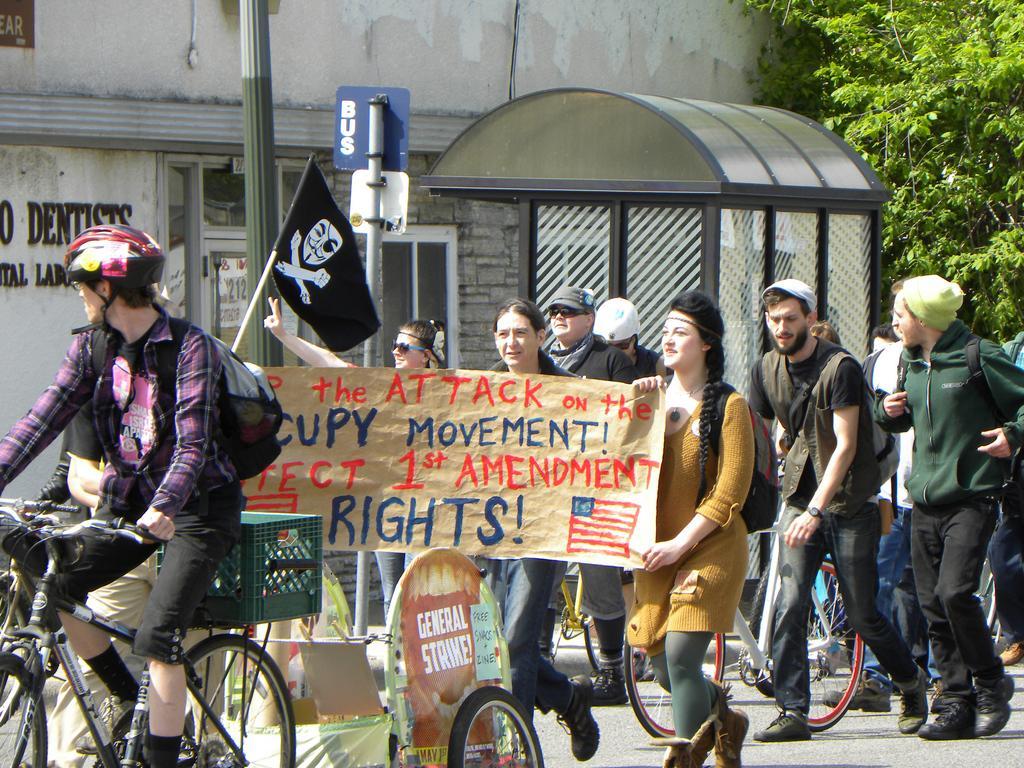Could you give a brief overview of what you see in this image? In this picture there is a man riding bicycle. There is a flag. There are group of people who are waking. There is a poster. There is a pole and a tree. 